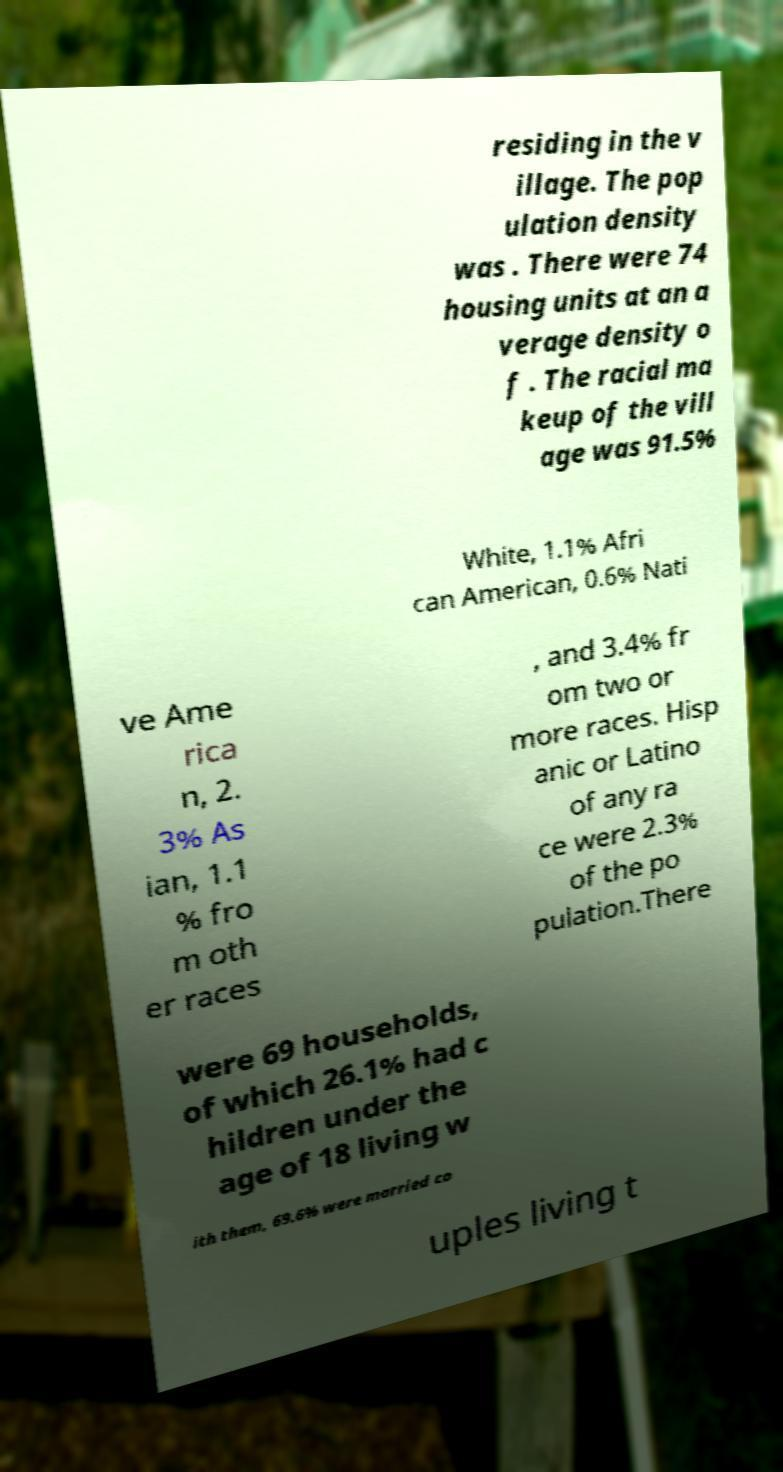Please identify and transcribe the text found in this image. residing in the v illage. The pop ulation density was . There were 74 housing units at an a verage density o f . The racial ma keup of the vill age was 91.5% White, 1.1% Afri can American, 0.6% Nati ve Ame rica n, 2. 3% As ian, 1.1 % fro m oth er races , and 3.4% fr om two or more races. Hisp anic or Latino of any ra ce were 2.3% of the po pulation.There were 69 households, of which 26.1% had c hildren under the age of 18 living w ith them, 69.6% were married co uples living t 